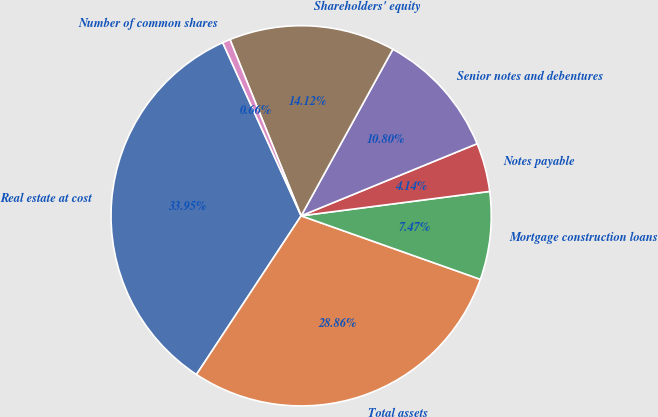Convert chart to OTSL. <chart><loc_0><loc_0><loc_500><loc_500><pie_chart><fcel>Real estate at cost<fcel>Total assets<fcel>Mortgage construction loans<fcel>Notes payable<fcel>Senior notes and debentures<fcel>Shareholders' equity<fcel>Number of common shares<nl><fcel>33.95%<fcel>28.86%<fcel>7.47%<fcel>4.14%<fcel>10.8%<fcel>14.12%<fcel>0.66%<nl></chart> 